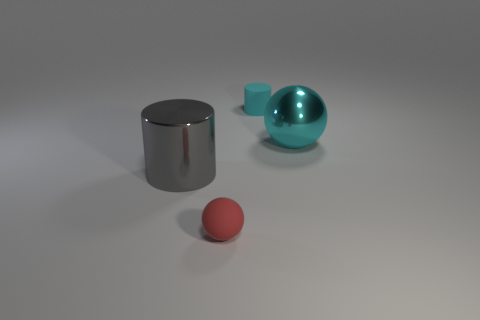Add 1 big cyan metallic things. How many objects exist? 5 Subtract 1 cylinders. How many cylinders are left? 1 Subtract all gray cylinders. How many cylinders are left? 1 Add 4 big cyan metallic balls. How many big cyan metallic balls are left? 5 Add 2 tiny purple cubes. How many tiny purple cubes exist? 2 Subtract 0 cyan cubes. How many objects are left? 4 Subtract all red balls. Subtract all gray cylinders. How many balls are left? 1 Subtract all red rubber spheres. Subtract all shiny cylinders. How many objects are left? 2 